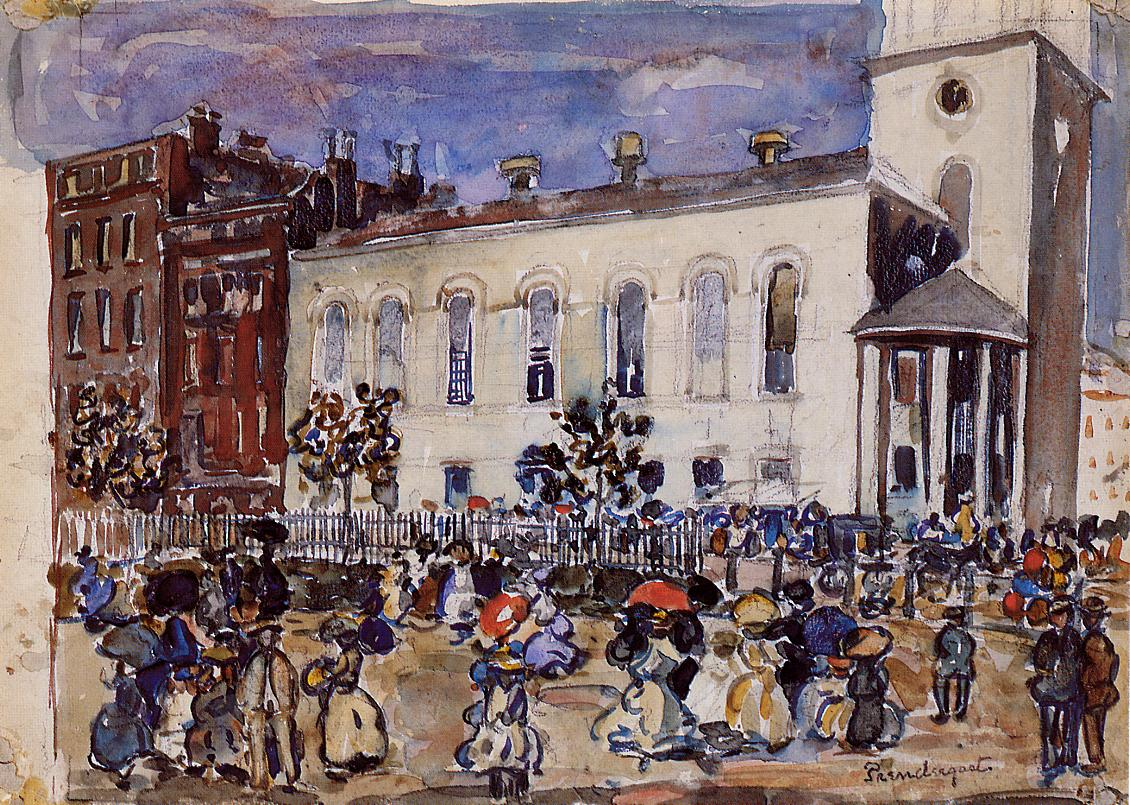What is the architectural significance of the white building in the background? The architecture of the white building is reflective of neoclassical design, characterized by its towering columns and symmetrical windows. This style was prevalent in the 18th and early 19th centuries, suggesting that the building might hold historical importance or serve a significant communal function, possibly a church, government building, or a monument. The stark white facade stands out against the soft, dynamic tones of the street scene, drawing the viewer's eye to its timeless design and possibly representing the enduring cultural or institutional foundations amidst the ever-changing flow of daily life.  How does the art style affect the viewer's impression of the painting? The impressionist style of the painting, with its loose brushstrokes and emphasis on light and color over line and definition, creates an impression of spontaneity and momentariness. This art style invites the viewer to appreciate the scene as a fleeting glimpse into a moment rather than a detailed narrative. It resonates with the ephemeral nature of memory and perception, suggesting that each person's experience of the scene could be unique. The viewer might feel drawn into the vibrancy of the street life, sensing the movement and energy as if it were a paused dance, beautiful in its impermanence. 